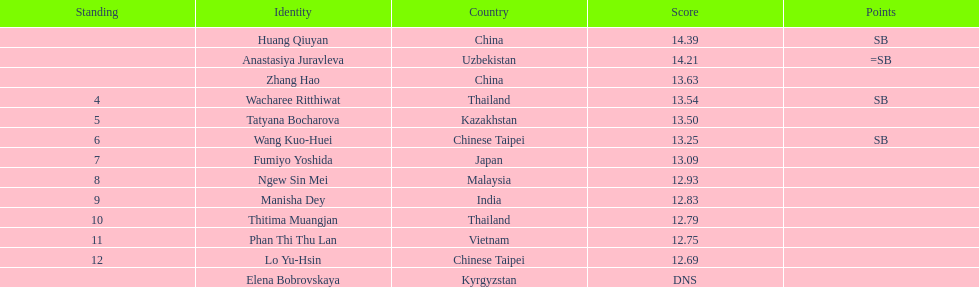Write the full table. {'header': ['Standing', 'Identity', 'Country', 'Score', 'Points'], 'rows': [['', 'Huang Qiuyan', 'China', '14.39', 'SB'], ['', 'Anastasiya Juravleva', 'Uzbekistan', '14.21', '=SB'], ['', 'Zhang Hao', 'China', '13.63', ''], ['4', 'Wacharee Ritthiwat', 'Thailand', '13.54', 'SB'], ['5', 'Tatyana Bocharova', 'Kazakhstan', '13.50', ''], ['6', 'Wang Kuo-Huei', 'Chinese Taipei', '13.25', 'SB'], ['7', 'Fumiyo Yoshida', 'Japan', '13.09', ''], ['8', 'Ngew Sin Mei', 'Malaysia', '12.93', ''], ['9', 'Manisha Dey', 'India', '12.83', ''], ['10', 'Thitima Muangjan', 'Thailand', '12.79', ''], ['11', 'Phan Thi Thu Lan', 'Vietnam', '12.75', ''], ['12', 'Lo Yu-Hsin', 'Chinese Taipei', '12.69', ''], ['', 'Elena Bobrovskaya', 'Kyrgyzstan', 'DNS', '']]} What is the number of different nationalities represented by the top 5 athletes? 4. 